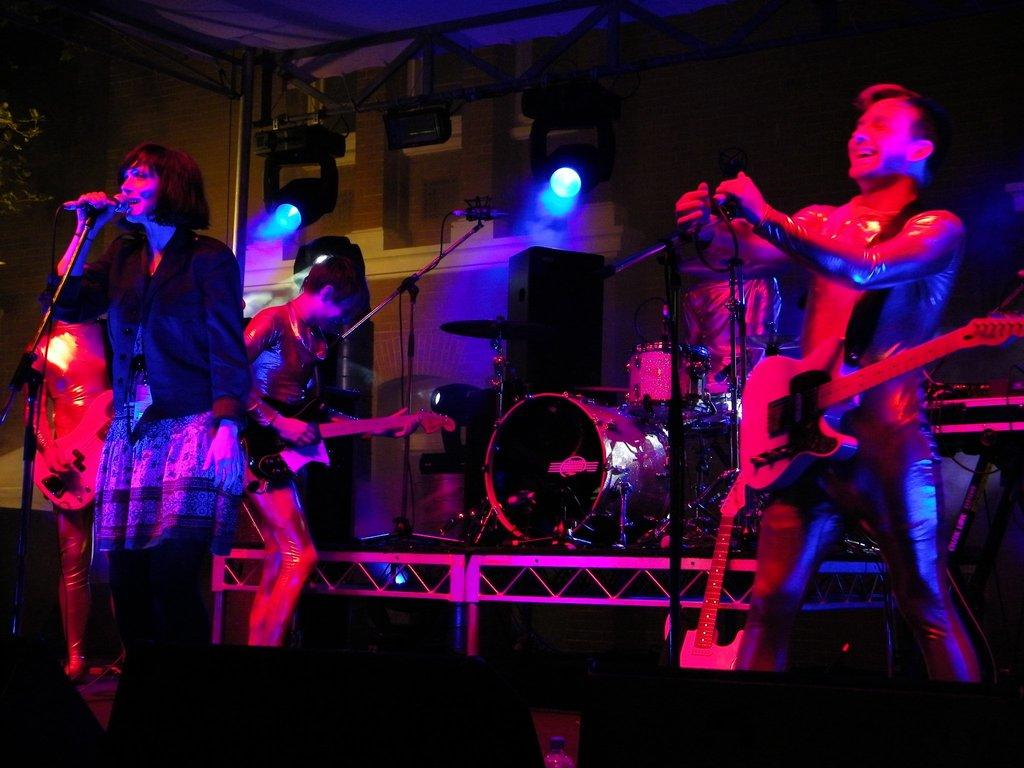What are the people in the image doing? The people in the image are holding musical instruments. What is the woman holding in the image? The woman is holding a microphone in the image. What additional feature can be seen in the image? DJ lights are visible in the image. Can you describe the trail of sugar leading to the microphone in the image? There is no trail of sugar present in the image. 